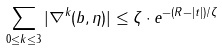Convert formula to latex. <formula><loc_0><loc_0><loc_500><loc_500>\sum _ { 0 \leq k \leq 3 } | \nabla ^ { k } ( b , \eta ) | \leq \zeta \cdot e ^ { - ( R - | t | ) / \zeta }</formula> 